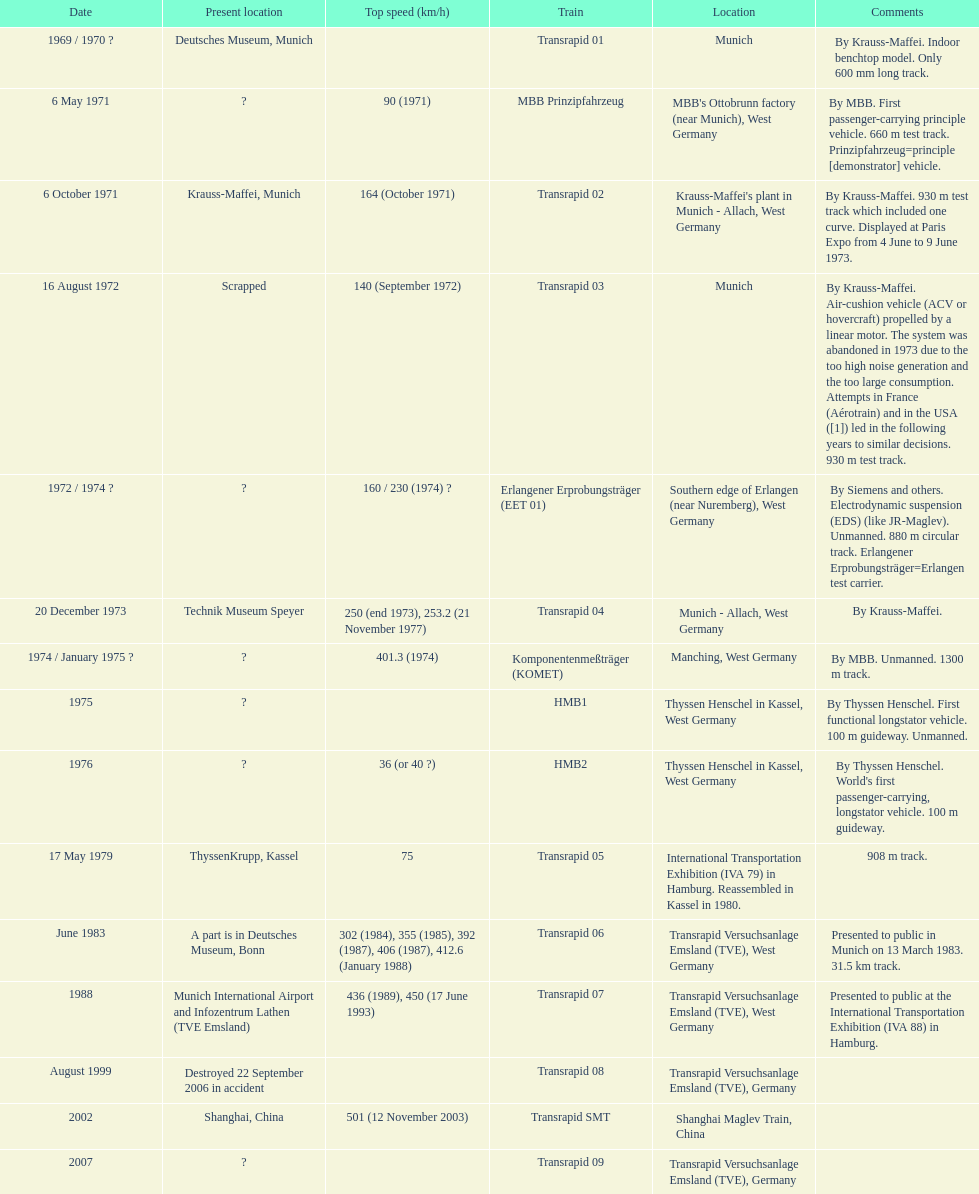High noise generation and too large consumption led to what train being scrapped? Transrapid 03. 